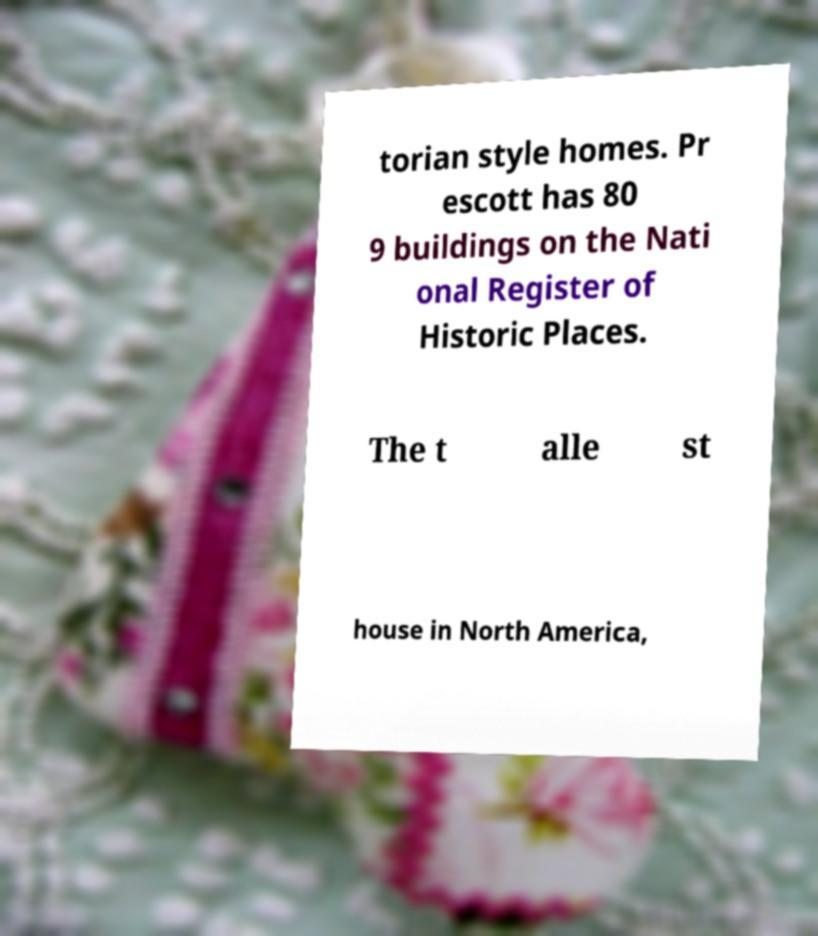Can you read and provide the text displayed in the image?This photo seems to have some interesting text. Can you extract and type it out for me? torian style homes. Pr escott has 80 9 buildings on the Nati onal Register of Historic Places. The t alle st house in North America, 